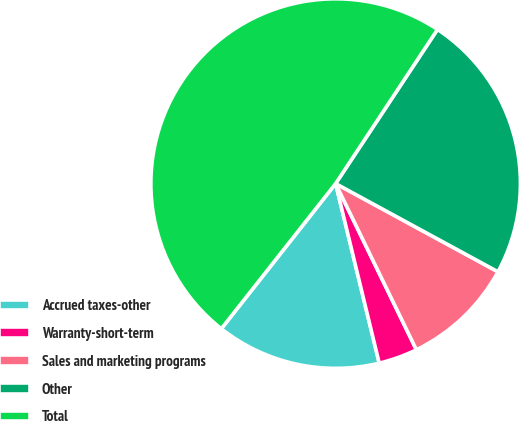Convert chart to OTSL. <chart><loc_0><loc_0><loc_500><loc_500><pie_chart><fcel>Accrued taxes-other<fcel>Warranty-short-term<fcel>Sales and marketing programs<fcel>Other<fcel>Total<nl><fcel>14.41%<fcel>3.41%<fcel>9.88%<fcel>23.63%<fcel>48.68%<nl></chart> 